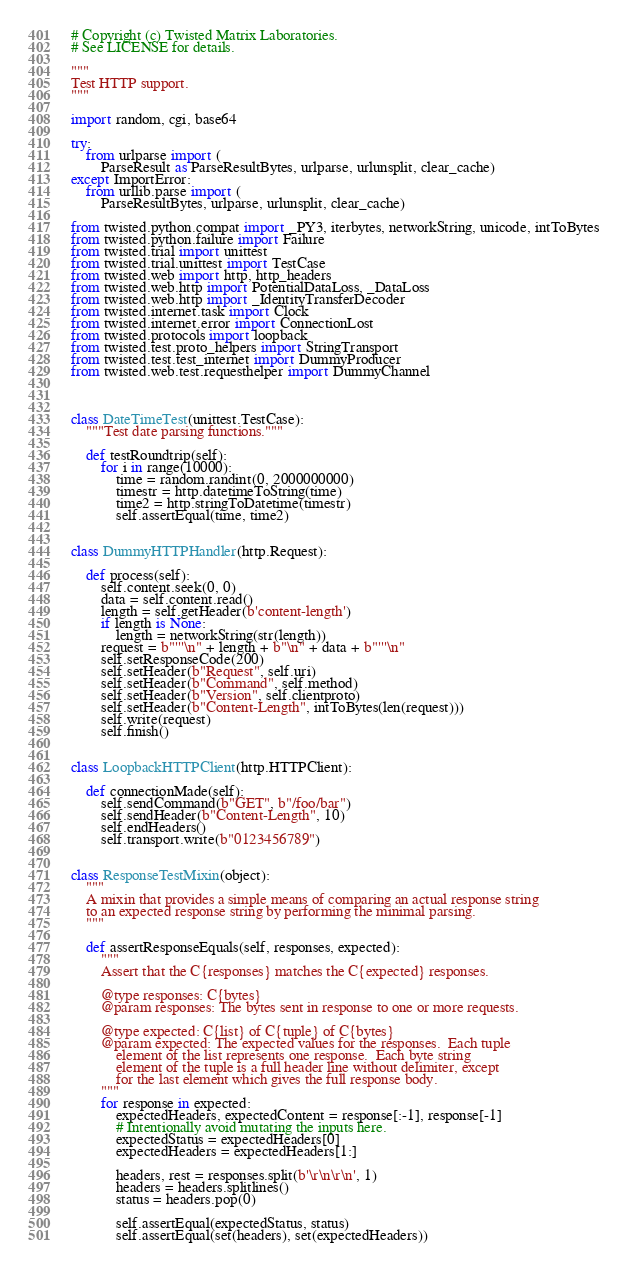<code> <loc_0><loc_0><loc_500><loc_500><_Python_># Copyright (c) Twisted Matrix Laboratories.
# See LICENSE for details.

"""
Test HTTP support.
"""

import random, cgi, base64

try:
    from urlparse import (
        ParseResult as ParseResultBytes, urlparse, urlunsplit, clear_cache)
except ImportError:
    from urllib.parse import (
        ParseResultBytes, urlparse, urlunsplit, clear_cache)

from twisted.python.compat import _PY3, iterbytes, networkString, unicode, intToBytes
from twisted.python.failure import Failure
from twisted.trial import unittest
from twisted.trial.unittest import TestCase
from twisted.web import http, http_headers
from twisted.web.http import PotentialDataLoss, _DataLoss
from twisted.web.http import _IdentityTransferDecoder
from twisted.internet.task import Clock
from twisted.internet.error import ConnectionLost
from twisted.protocols import loopback
from twisted.test.proto_helpers import StringTransport
from twisted.test.test_internet import DummyProducer
from twisted.web.test.requesthelper import DummyChannel



class DateTimeTest(unittest.TestCase):
    """Test date parsing functions."""

    def testRoundtrip(self):
        for i in range(10000):
            time = random.randint(0, 2000000000)
            timestr = http.datetimeToString(time)
            time2 = http.stringToDatetime(timestr)
            self.assertEqual(time, time2)


class DummyHTTPHandler(http.Request):

    def process(self):
        self.content.seek(0, 0)
        data = self.content.read()
        length = self.getHeader(b'content-length')
        if length is None:
            length = networkString(str(length))
        request = b"'''\n" + length + b"\n" + data + b"'''\n"
        self.setResponseCode(200)
        self.setHeader(b"Request", self.uri)
        self.setHeader(b"Command", self.method)
        self.setHeader(b"Version", self.clientproto)
        self.setHeader(b"Content-Length", intToBytes(len(request)))
        self.write(request)
        self.finish()


class LoopbackHTTPClient(http.HTTPClient):

    def connectionMade(self):
        self.sendCommand(b"GET", b"/foo/bar")
        self.sendHeader(b"Content-Length", 10)
        self.endHeaders()
        self.transport.write(b"0123456789")


class ResponseTestMixin(object):
    """
    A mixin that provides a simple means of comparing an actual response string
    to an expected response string by performing the minimal parsing.
    """

    def assertResponseEquals(self, responses, expected):
        """
        Assert that the C{responses} matches the C{expected} responses.

        @type responses: C{bytes}
        @param responses: The bytes sent in response to one or more requests.

        @type expected: C{list} of C{tuple} of C{bytes}
        @param expected: The expected values for the responses.  Each tuple
            element of the list represents one response.  Each byte string
            element of the tuple is a full header line without delimiter, except
            for the last element which gives the full response body.
        """
        for response in expected:
            expectedHeaders, expectedContent = response[:-1], response[-1]
            # Intentionally avoid mutating the inputs here.
            expectedStatus = expectedHeaders[0]
            expectedHeaders = expectedHeaders[1:]

            headers, rest = responses.split(b'\r\n\r\n', 1)
            headers = headers.splitlines()
            status = headers.pop(0)

            self.assertEqual(expectedStatus, status)
            self.assertEqual(set(headers), set(expectedHeaders))</code> 